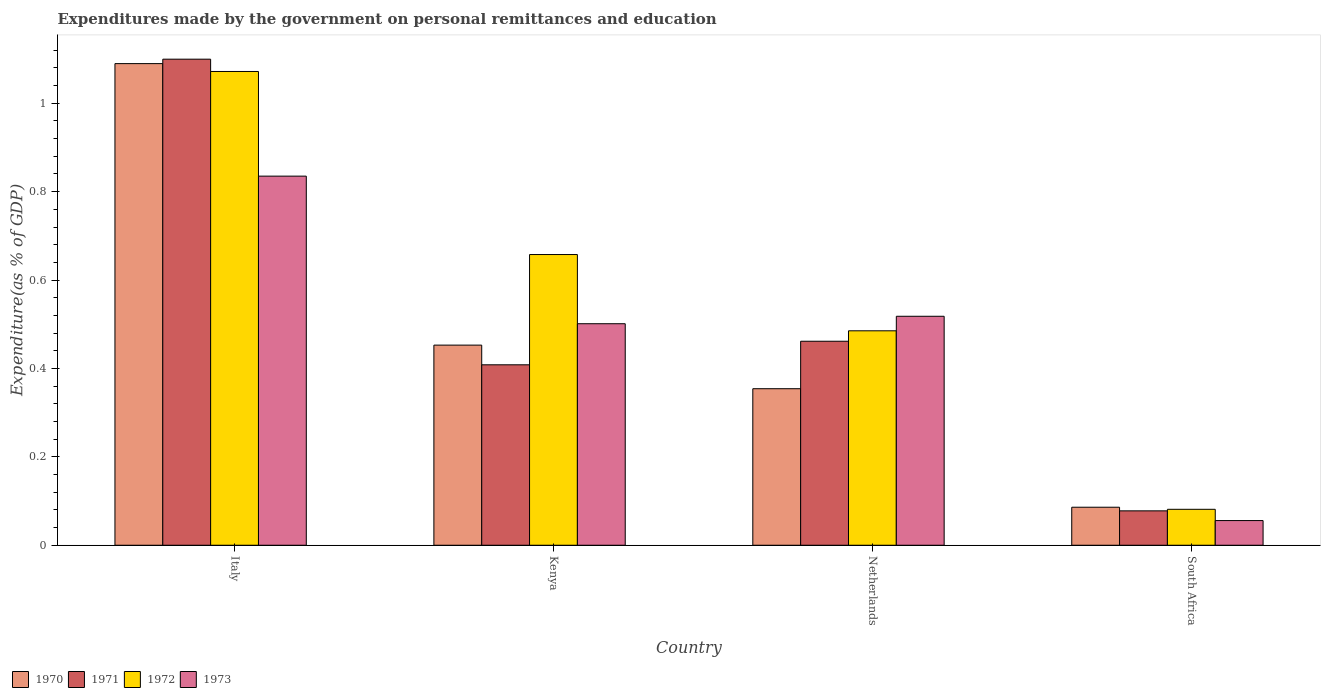How many different coloured bars are there?
Make the answer very short. 4. Are the number of bars on each tick of the X-axis equal?
Offer a terse response. Yes. How many bars are there on the 4th tick from the left?
Your answer should be very brief. 4. How many bars are there on the 4th tick from the right?
Offer a very short reply. 4. What is the label of the 4th group of bars from the left?
Give a very brief answer. South Africa. What is the expenditures made by the government on personal remittances and education in 1973 in Netherlands?
Provide a short and direct response. 0.52. Across all countries, what is the maximum expenditures made by the government on personal remittances and education in 1971?
Make the answer very short. 1.1. Across all countries, what is the minimum expenditures made by the government on personal remittances and education in 1973?
Your response must be concise. 0.06. In which country was the expenditures made by the government on personal remittances and education in 1971 maximum?
Keep it short and to the point. Italy. In which country was the expenditures made by the government on personal remittances and education in 1970 minimum?
Keep it short and to the point. South Africa. What is the total expenditures made by the government on personal remittances and education in 1973 in the graph?
Offer a very short reply. 1.91. What is the difference between the expenditures made by the government on personal remittances and education in 1972 in Netherlands and that in South Africa?
Provide a succinct answer. 0.4. What is the difference between the expenditures made by the government on personal remittances and education in 1971 in South Africa and the expenditures made by the government on personal remittances and education in 1972 in Italy?
Give a very brief answer. -0.99. What is the average expenditures made by the government on personal remittances and education in 1970 per country?
Make the answer very short. 0.5. What is the difference between the expenditures made by the government on personal remittances and education of/in 1973 and expenditures made by the government on personal remittances and education of/in 1972 in Netherlands?
Ensure brevity in your answer.  0.03. In how many countries, is the expenditures made by the government on personal remittances and education in 1971 greater than 0.2 %?
Your response must be concise. 3. What is the ratio of the expenditures made by the government on personal remittances and education in 1973 in Italy to that in South Africa?
Offer a very short reply. 14.96. Is the expenditures made by the government on personal remittances and education in 1972 in Kenya less than that in Netherlands?
Your response must be concise. No. What is the difference between the highest and the second highest expenditures made by the government on personal remittances and education in 1973?
Your answer should be compact. 0.32. What is the difference between the highest and the lowest expenditures made by the government on personal remittances and education in 1972?
Make the answer very short. 0.99. Is it the case that in every country, the sum of the expenditures made by the government on personal remittances and education in 1973 and expenditures made by the government on personal remittances and education in 1970 is greater than the sum of expenditures made by the government on personal remittances and education in 1971 and expenditures made by the government on personal remittances and education in 1972?
Give a very brief answer. No. What does the 2nd bar from the right in Kenya represents?
Ensure brevity in your answer.  1972. Is it the case that in every country, the sum of the expenditures made by the government on personal remittances and education in 1971 and expenditures made by the government on personal remittances and education in 1973 is greater than the expenditures made by the government on personal remittances and education in 1972?
Provide a succinct answer. Yes. How many countries are there in the graph?
Keep it short and to the point. 4. What is the difference between two consecutive major ticks on the Y-axis?
Give a very brief answer. 0.2. Does the graph contain grids?
Provide a succinct answer. No. How are the legend labels stacked?
Provide a succinct answer. Horizontal. What is the title of the graph?
Offer a very short reply. Expenditures made by the government on personal remittances and education. Does "2001" appear as one of the legend labels in the graph?
Your response must be concise. No. What is the label or title of the Y-axis?
Your answer should be compact. Expenditure(as % of GDP). What is the Expenditure(as % of GDP) in 1970 in Italy?
Your response must be concise. 1.09. What is the Expenditure(as % of GDP) of 1971 in Italy?
Ensure brevity in your answer.  1.1. What is the Expenditure(as % of GDP) of 1972 in Italy?
Provide a succinct answer. 1.07. What is the Expenditure(as % of GDP) of 1973 in Italy?
Keep it short and to the point. 0.84. What is the Expenditure(as % of GDP) in 1970 in Kenya?
Provide a succinct answer. 0.45. What is the Expenditure(as % of GDP) in 1971 in Kenya?
Provide a short and direct response. 0.41. What is the Expenditure(as % of GDP) in 1972 in Kenya?
Your answer should be compact. 0.66. What is the Expenditure(as % of GDP) of 1973 in Kenya?
Provide a succinct answer. 0.5. What is the Expenditure(as % of GDP) of 1970 in Netherlands?
Provide a succinct answer. 0.35. What is the Expenditure(as % of GDP) of 1971 in Netherlands?
Keep it short and to the point. 0.46. What is the Expenditure(as % of GDP) in 1972 in Netherlands?
Offer a very short reply. 0.49. What is the Expenditure(as % of GDP) in 1973 in Netherlands?
Provide a succinct answer. 0.52. What is the Expenditure(as % of GDP) of 1970 in South Africa?
Provide a succinct answer. 0.09. What is the Expenditure(as % of GDP) in 1971 in South Africa?
Your answer should be compact. 0.08. What is the Expenditure(as % of GDP) of 1972 in South Africa?
Ensure brevity in your answer.  0.08. What is the Expenditure(as % of GDP) of 1973 in South Africa?
Ensure brevity in your answer.  0.06. Across all countries, what is the maximum Expenditure(as % of GDP) of 1970?
Offer a terse response. 1.09. Across all countries, what is the maximum Expenditure(as % of GDP) in 1971?
Ensure brevity in your answer.  1.1. Across all countries, what is the maximum Expenditure(as % of GDP) in 1972?
Your answer should be compact. 1.07. Across all countries, what is the maximum Expenditure(as % of GDP) in 1973?
Provide a short and direct response. 0.84. Across all countries, what is the minimum Expenditure(as % of GDP) of 1970?
Offer a very short reply. 0.09. Across all countries, what is the minimum Expenditure(as % of GDP) of 1971?
Your response must be concise. 0.08. Across all countries, what is the minimum Expenditure(as % of GDP) in 1972?
Ensure brevity in your answer.  0.08. Across all countries, what is the minimum Expenditure(as % of GDP) of 1973?
Provide a short and direct response. 0.06. What is the total Expenditure(as % of GDP) in 1970 in the graph?
Offer a terse response. 1.98. What is the total Expenditure(as % of GDP) in 1971 in the graph?
Give a very brief answer. 2.05. What is the total Expenditure(as % of GDP) in 1972 in the graph?
Keep it short and to the point. 2.3. What is the total Expenditure(as % of GDP) of 1973 in the graph?
Give a very brief answer. 1.91. What is the difference between the Expenditure(as % of GDP) in 1970 in Italy and that in Kenya?
Offer a very short reply. 0.64. What is the difference between the Expenditure(as % of GDP) in 1971 in Italy and that in Kenya?
Make the answer very short. 0.69. What is the difference between the Expenditure(as % of GDP) in 1972 in Italy and that in Kenya?
Provide a succinct answer. 0.41. What is the difference between the Expenditure(as % of GDP) of 1973 in Italy and that in Kenya?
Provide a short and direct response. 0.33. What is the difference between the Expenditure(as % of GDP) in 1970 in Italy and that in Netherlands?
Keep it short and to the point. 0.74. What is the difference between the Expenditure(as % of GDP) in 1971 in Italy and that in Netherlands?
Give a very brief answer. 0.64. What is the difference between the Expenditure(as % of GDP) of 1972 in Italy and that in Netherlands?
Make the answer very short. 0.59. What is the difference between the Expenditure(as % of GDP) of 1973 in Italy and that in Netherlands?
Your answer should be compact. 0.32. What is the difference between the Expenditure(as % of GDP) of 1970 in Italy and that in South Africa?
Offer a terse response. 1. What is the difference between the Expenditure(as % of GDP) in 1971 in Italy and that in South Africa?
Keep it short and to the point. 1.02. What is the difference between the Expenditure(as % of GDP) in 1972 in Italy and that in South Africa?
Offer a very short reply. 0.99. What is the difference between the Expenditure(as % of GDP) in 1973 in Italy and that in South Africa?
Your response must be concise. 0.78. What is the difference between the Expenditure(as % of GDP) of 1970 in Kenya and that in Netherlands?
Your answer should be very brief. 0.1. What is the difference between the Expenditure(as % of GDP) in 1971 in Kenya and that in Netherlands?
Give a very brief answer. -0.05. What is the difference between the Expenditure(as % of GDP) in 1972 in Kenya and that in Netherlands?
Give a very brief answer. 0.17. What is the difference between the Expenditure(as % of GDP) in 1973 in Kenya and that in Netherlands?
Give a very brief answer. -0.02. What is the difference between the Expenditure(as % of GDP) of 1970 in Kenya and that in South Africa?
Make the answer very short. 0.37. What is the difference between the Expenditure(as % of GDP) in 1971 in Kenya and that in South Africa?
Your response must be concise. 0.33. What is the difference between the Expenditure(as % of GDP) in 1972 in Kenya and that in South Africa?
Give a very brief answer. 0.58. What is the difference between the Expenditure(as % of GDP) of 1973 in Kenya and that in South Africa?
Provide a succinct answer. 0.45. What is the difference between the Expenditure(as % of GDP) of 1970 in Netherlands and that in South Africa?
Make the answer very short. 0.27. What is the difference between the Expenditure(as % of GDP) in 1971 in Netherlands and that in South Africa?
Ensure brevity in your answer.  0.38. What is the difference between the Expenditure(as % of GDP) in 1972 in Netherlands and that in South Africa?
Offer a very short reply. 0.4. What is the difference between the Expenditure(as % of GDP) in 1973 in Netherlands and that in South Africa?
Provide a short and direct response. 0.46. What is the difference between the Expenditure(as % of GDP) in 1970 in Italy and the Expenditure(as % of GDP) in 1971 in Kenya?
Offer a very short reply. 0.68. What is the difference between the Expenditure(as % of GDP) of 1970 in Italy and the Expenditure(as % of GDP) of 1972 in Kenya?
Ensure brevity in your answer.  0.43. What is the difference between the Expenditure(as % of GDP) of 1970 in Italy and the Expenditure(as % of GDP) of 1973 in Kenya?
Your response must be concise. 0.59. What is the difference between the Expenditure(as % of GDP) of 1971 in Italy and the Expenditure(as % of GDP) of 1972 in Kenya?
Offer a very short reply. 0.44. What is the difference between the Expenditure(as % of GDP) in 1971 in Italy and the Expenditure(as % of GDP) in 1973 in Kenya?
Give a very brief answer. 0.6. What is the difference between the Expenditure(as % of GDP) of 1972 in Italy and the Expenditure(as % of GDP) of 1973 in Kenya?
Offer a very short reply. 0.57. What is the difference between the Expenditure(as % of GDP) of 1970 in Italy and the Expenditure(as % of GDP) of 1971 in Netherlands?
Provide a succinct answer. 0.63. What is the difference between the Expenditure(as % of GDP) in 1970 in Italy and the Expenditure(as % of GDP) in 1972 in Netherlands?
Your answer should be compact. 0.6. What is the difference between the Expenditure(as % of GDP) of 1970 in Italy and the Expenditure(as % of GDP) of 1973 in Netherlands?
Provide a short and direct response. 0.57. What is the difference between the Expenditure(as % of GDP) of 1971 in Italy and the Expenditure(as % of GDP) of 1972 in Netherlands?
Provide a succinct answer. 0.61. What is the difference between the Expenditure(as % of GDP) of 1971 in Italy and the Expenditure(as % of GDP) of 1973 in Netherlands?
Keep it short and to the point. 0.58. What is the difference between the Expenditure(as % of GDP) in 1972 in Italy and the Expenditure(as % of GDP) in 1973 in Netherlands?
Your answer should be compact. 0.55. What is the difference between the Expenditure(as % of GDP) of 1970 in Italy and the Expenditure(as % of GDP) of 1971 in South Africa?
Provide a short and direct response. 1.01. What is the difference between the Expenditure(as % of GDP) of 1970 in Italy and the Expenditure(as % of GDP) of 1972 in South Africa?
Offer a very short reply. 1.01. What is the difference between the Expenditure(as % of GDP) in 1970 in Italy and the Expenditure(as % of GDP) in 1973 in South Africa?
Provide a short and direct response. 1.03. What is the difference between the Expenditure(as % of GDP) of 1971 in Italy and the Expenditure(as % of GDP) of 1972 in South Africa?
Provide a short and direct response. 1.02. What is the difference between the Expenditure(as % of GDP) of 1971 in Italy and the Expenditure(as % of GDP) of 1973 in South Africa?
Make the answer very short. 1.04. What is the difference between the Expenditure(as % of GDP) in 1970 in Kenya and the Expenditure(as % of GDP) in 1971 in Netherlands?
Your response must be concise. -0.01. What is the difference between the Expenditure(as % of GDP) of 1970 in Kenya and the Expenditure(as % of GDP) of 1972 in Netherlands?
Ensure brevity in your answer.  -0.03. What is the difference between the Expenditure(as % of GDP) of 1970 in Kenya and the Expenditure(as % of GDP) of 1973 in Netherlands?
Provide a succinct answer. -0.07. What is the difference between the Expenditure(as % of GDP) of 1971 in Kenya and the Expenditure(as % of GDP) of 1972 in Netherlands?
Make the answer very short. -0.08. What is the difference between the Expenditure(as % of GDP) of 1971 in Kenya and the Expenditure(as % of GDP) of 1973 in Netherlands?
Your response must be concise. -0.11. What is the difference between the Expenditure(as % of GDP) in 1972 in Kenya and the Expenditure(as % of GDP) in 1973 in Netherlands?
Give a very brief answer. 0.14. What is the difference between the Expenditure(as % of GDP) in 1970 in Kenya and the Expenditure(as % of GDP) in 1971 in South Africa?
Your response must be concise. 0.38. What is the difference between the Expenditure(as % of GDP) of 1970 in Kenya and the Expenditure(as % of GDP) of 1972 in South Africa?
Your response must be concise. 0.37. What is the difference between the Expenditure(as % of GDP) in 1970 in Kenya and the Expenditure(as % of GDP) in 1973 in South Africa?
Make the answer very short. 0.4. What is the difference between the Expenditure(as % of GDP) in 1971 in Kenya and the Expenditure(as % of GDP) in 1972 in South Africa?
Provide a short and direct response. 0.33. What is the difference between the Expenditure(as % of GDP) in 1971 in Kenya and the Expenditure(as % of GDP) in 1973 in South Africa?
Ensure brevity in your answer.  0.35. What is the difference between the Expenditure(as % of GDP) in 1972 in Kenya and the Expenditure(as % of GDP) in 1973 in South Africa?
Keep it short and to the point. 0.6. What is the difference between the Expenditure(as % of GDP) in 1970 in Netherlands and the Expenditure(as % of GDP) in 1971 in South Africa?
Your response must be concise. 0.28. What is the difference between the Expenditure(as % of GDP) of 1970 in Netherlands and the Expenditure(as % of GDP) of 1972 in South Africa?
Your answer should be very brief. 0.27. What is the difference between the Expenditure(as % of GDP) in 1970 in Netherlands and the Expenditure(as % of GDP) in 1973 in South Africa?
Offer a very short reply. 0.3. What is the difference between the Expenditure(as % of GDP) in 1971 in Netherlands and the Expenditure(as % of GDP) in 1972 in South Africa?
Your answer should be very brief. 0.38. What is the difference between the Expenditure(as % of GDP) of 1971 in Netherlands and the Expenditure(as % of GDP) of 1973 in South Africa?
Give a very brief answer. 0.41. What is the difference between the Expenditure(as % of GDP) of 1972 in Netherlands and the Expenditure(as % of GDP) of 1973 in South Africa?
Ensure brevity in your answer.  0.43. What is the average Expenditure(as % of GDP) in 1970 per country?
Keep it short and to the point. 0.5. What is the average Expenditure(as % of GDP) in 1971 per country?
Offer a very short reply. 0.51. What is the average Expenditure(as % of GDP) in 1972 per country?
Your answer should be very brief. 0.57. What is the average Expenditure(as % of GDP) in 1973 per country?
Ensure brevity in your answer.  0.48. What is the difference between the Expenditure(as % of GDP) in 1970 and Expenditure(as % of GDP) in 1971 in Italy?
Your answer should be very brief. -0.01. What is the difference between the Expenditure(as % of GDP) in 1970 and Expenditure(as % of GDP) in 1972 in Italy?
Give a very brief answer. 0.02. What is the difference between the Expenditure(as % of GDP) in 1970 and Expenditure(as % of GDP) in 1973 in Italy?
Your answer should be very brief. 0.25. What is the difference between the Expenditure(as % of GDP) of 1971 and Expenditure(as % of GDP) of 1972 in Italy?
Provide a succinct answer. 0.03. What is the difference between the Expenditure(as % of GDP) of 1971 and Expenditure(as % of GDP) of 1973 in Italy?
Provide a short and direct response. 0.26. What is the difference between the Expenditure(as % of GDP) of 1972 and Expenditure(as % of GDP) of 1973 in Italy?
Your answer should be very brief. 0.24. What is the difference between the Expenditure(as % of GDP) in 1970 and Expenditure(as % of GDP) in 1971 in Kenya?
Your response must be concise. 0.04. What is the difference between the Expenditure(as % of GDP) of 1970 and Expenditure(as % of GDP) of 1972 in Kenya?
Keep it short and to the point. -0.2. What is the difference between the Expenditure(as % of GDP) of 1970 and Expenditure(as % of GDP) of 1973 in Kenya?
Your answer should be compact. -0.05. What is the difference between the Expenditure(as % of GDP) in 1971 and Expenditure(as % of GDP) in 1972 in Kenya?
Your answer should be compact. -0.25. What is the difference between the Expenditure(as % of GDP) of 1971 and Expenditure(as % of GDP) of 1973 in Kenya?
Ensure brevity in your answer.  -0.09. What is the difference between the Expenditure(as % of GDP) of 1972 and Expenditure(as % of GDP) of 1973 in Kenya?
Offer a very short reply. 0.16. What is the difference between the Expenditure(as % of GDP) in 1970 and Expenditure(as % of GDP) in 1971 in Netherlands?
Your response must be concise. -0.11. What is the difference between the Expenditure(as % of GDP) in 1970 and Expenditure(as % of GDP) in 1972 in Netherlands?
Provide a short and direct response. -0.13. What is the difference between the Expenditure(as % of GDP) in 1970 and Expenditure(as % of GDP) in 1973 in Netherlands?
Your answer should be compact. -0.16. What is the difference between the Expenditure(as % of GDP) of 1971 and Expenditure(as % of GDP) of 1972 in Netherlands?
Make the answer very short. -0.02. What is the difference between the Expenditure(as % of GDP) in 1971 and Expenditure(as % of GDP) in 1973 in Netherlands?
Your answer should be compact. -0.06. What is the difference between the Expenditure(as % of GDP) of 1972 and Expenditure(as % of GDP) of 1973 in Netherlands?
Your response must be concise. -0.03. What is the difference between the Expenditure(as % of GDP) in 1970 and Expenditure(as % of GDP) in 1971 in South Africa?
Keep it short and to the point. 0.01. What is the difference between the Expenditure(as % of GDP) of 1970 and Expenditure(as % of GDP) of 1972 in South Africa?
Offer a terse response. 0. What is the difference between the Expenditure(as % of GDP) in 1970 and Expenditure(as % of GDP) in 1973 in South Africa?
Provide a succinct answer. 0.03. What is the difference between the Expenditure(as % of GDP) in 1971 and Expenditure(as % of GDP) in 1972 in South Africa?
Keep it short and to the point. -0. What is the difference between the Expenditure(as % of GDP) in 1971 and Expenditure(as % of GDP) in 1973 in South Africa?
Ensure brevity in your answer.  0.02. What is the difference between the Expenditure(as % of GDP) of 1972 and Expenditure(as % of GDP) of 1973 in South Africa?
Ensure brevity in your answer.  0.03. What is the ratio of the Expenditure(as % of GDP) in 1970 in Italy to that in Kenya?
Provide a succinct answer. 2.41. What is the ratio of the Expenditure(as % of GDP) in 1971 in Italy to that in Kenya?
Offer a terse response. 2.69. What is the ratio of the Expenditure(as % of GDP) in 1972 in Italy to that in Kenya?
Make the answer very short. 1.63. What is the ratio of the Expenditure(as % of GDP) of 1973 in Italy to that in Kenya?
Your answer should be very brief. 1.67. What is the ratio of the Expenditure(as % of GDP) in 1970 in Italy to that in Netherlands?
Your answer should be compact. 3.08. What is the ratio of the Expenditure(as % of GDP) in 1971 in Italy to that in Netherlands?
Your answer should be very brief. 2.38. What is the ratio of the Expenditure(as % of GDP) in 1972 in Italy to that in Netherlands?
Provide a short and direct response. 2.21. What is the ratio of the Expenditure(as % of GDP) of 1973 in Italy to that in Netherlands?
Offer a very short reply. 1.61. What is the ratio of the Expenditure(as % of GDP) of 1970 in Italy to that in South Africa?
Make the answer very short. 12.67. What is the ratio of the Expenditure(as % of GDP) in 1971 in Italy to that in South Africa?
Ensure brevity in your answer.  14.13. What is the ratio of the Expenditure(as % of GDP) of 1972 in Italy to that in South Africa?
Ensure brevity in your answer.  13.18. What is the ratio of the Expenditure(as % of GDP) of 1973 in Italy to that in South Africa?
Your answer should be very brief. 14.96. What is the ratio of the Expenditure(as % of GDP) of 1970 in Kenya to that in Netherlands?
Provide a short and direct response. 1.28. What is the ratio of the Expenditure(as % of GDP) in 1971 in Kenya to that in Netherlands?
Provide a short and direct response. 0.88. What is the ratio of the Expenditure(as % of GDP) in 1972 in Kenya to that in Netherlands?
Offer a terse response. 1.36. What is the ratio of the Expenditure(as % of GDP) in 1973 in Kenya to that in Netherlands?
Offer a terse response. 0.97. What is the ratio of the Expenditure(as % of GDP) of 1970 in Kenya to that in South Africa?
Your response must be concise. 5.26. What is the ratio of the Expenditure(as % of GDP) in 1971 in Kenya to that in South Africa?
Your response must be concise. 5.25. What is the ratio of the Expenditure(as % of GDP) of 1972 in Kenya to that in South Africa?
Keep it short and to the point. 8.09. What is the ratio of the Expenditure(as % of GDP) in 1973 in Kenya to that in South Africa?
Provide a succinct answer. 8.98. What is the ratio of the Expenditure(as % of GDP) in 1970 in Netherlands to that in South Africa?
Provide a short and direct response. 4.12. What is the ratio of the Expenditure(as % of GDP) in 1971 in Netherlands to that in South Africa?
Your answer should be compact. 5.93. What is the ratio of the Expenditure(as % of GDP) in 1972 in Netherlands to that in South Africa?
Ensure brevity in your answer.  5.97. What is the ratio of the Expenditure(as % of GDP) in 1973 in Netherlands to that in South Africa?
Your answer should be compact. 9.28. What is the difference between the highest and the second highest Expenditure(as % of GDP) of 1970?
Ensure brevity in your answer.  0.64. What is the difference between the highest and the second highest Expenditure(as % of GDP) in 1971?
Keep it short and to the point. 0.64. What is the difference between the highest and the second highest Expenditure(as % of GDP) in 1972?
Provide a short and direct response. 0.41. What is the difference between the highest and the second highest Expenditure(as % of GDP) of 1973?
Provide a succinct answer. 0.32. What is the difference between the highest and the lowest Expenditure(as % of GDP) in 1971?
Offer a very short reply. 1.02. What is the difference between the highest and the lowest Expenditure(as % of GDP) of 1972?
Your answer should be very brief. 0.99. What is the difference between the highest and the lowest Expenditure(as % of GDP) in 1973?
Your response must be concise. 0.78. 